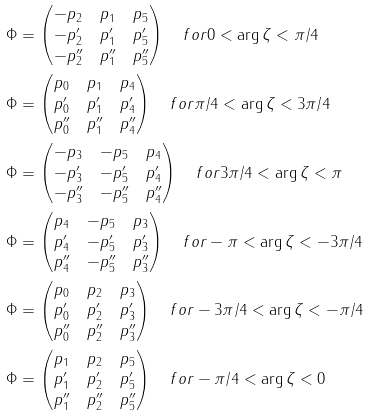<formula> <loc_0><loc_0><loc_500><loc_500>\Phi & = \begin{pmatrix} - p _ { 2 } & p _ { 1 } & p _ { 5 } \\ - p _ { 2 } ^ { \prime } & p _ { 1 } ^ { \prime } & p _ { 5 } ^ { \prime } \\ - p _ { 2 } ^ { \prime \prime } & p _ { 1 } ^ { \prime \prime } & p _ { 5 } ^ { \prime \prime } \end{pmatrix} \quad f o r 0 < \arg \zeta < \pi / 4 \\ \Phi & = \begin{pmatrix} p _ { 0 } & p _ { 1 } & p _ { 4 } \\ p _ { 0 } ^ { \prime } & p _ { 1 } ^ { \prime } & p _ { 4 } ^ { \prime } \\ p _ { 0 } ^ { \prime \prime } & p _ { 1 } ^ { \prime \prime } & p _ { 4 } ^ { \prime \prime } \end{pmatrix} \quad f o r \pi / 4 < \arg \zeta < 3 \pi / 4 \\ \Phi & = \begin{pmatrix} - p _ { 3 } & - p _ { 5 } & p _ { 4 } \\ - p _ { 3 } ^ { \prime } & - p _ { 5 } ^ { \prime } & p _ { 4 } ^ { \prime } \\ - p _ { 3 } ^ { \prime \prime } & - p _ { 5 } ^ { \prime \prime } & p _ { 4 } ^ { \prime \prime } \end{pmatrix} \quad f o r 3 \pi / 4 < \arg \zeta < \pi \\ \Phi & = \begin{pmatrix} p _ { 4 } & - p _ { 5 } & p _ { 3 } \\ p _ { 4 } ^ { \prime } & - p _ { 5 } ^ { \prime } & p _ { 3 } ^ { \prime } \\ p _ { 4 } ^ { \prime \prime } & - p _ { 5 } ^ { \prime \prime } & p _ { 3 } ^ { \prime \prime } \end{pmatrix} \quad f o r - \pi < \arg \zeta < - 3 \pi / 4 \\ \Phi & = \begin{pmatrix} p _ { 0 } & p _ { 2 } & p _ { 3 } \\ p _ { 0 } ^ { \prime } & p _ { 2 } ^ { \prime } & p _ { 3 } ^ { \prime } \\ p _ { 0 } ^ { \prime \prime } & p _ { 2 } ^ { \prime \prime } & p _ { 3 } ^ { \prime \prime } \end{pmatrix} \quad f o r - 3 \pi / 4 < \arg \zeta < - \pi / 4 \\ \Phi & = \begin{pmatrix} p _ { 1 } & p _ { 2 } & p _ { 5 } \\ p _ { 1 } ^ { \prime } & p _ { 2 } ^ { \prime } & p _ { 5 } ^ { \prime } \\ p _ { 1 } ^ { \prime \prime } & p _ { 2 } ^ { \prime \prime } & p _ { 5 } ^ { \prime \prime } \end{pmatrix} \quad f o r - \pi / 4 < \arg \zeta < 0</formula> 